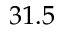<formula> <loc_0><loc_0><loc_500><loc_500>3 1 . 5</formula> 